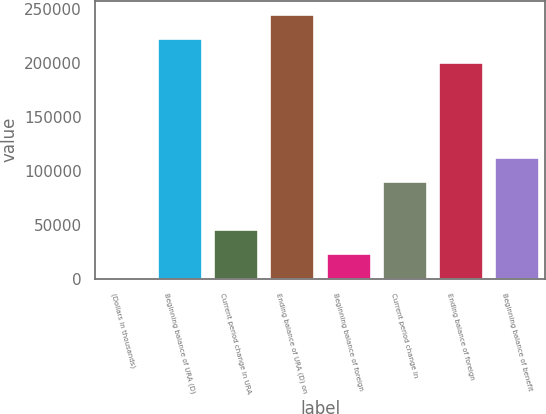Convert chart. <chart><loc_0><loc_0><loc_500><loc_500><bar_chart><fcel>(Dollars in thousands)<fcel>Beginning balance of URA (D)<fcel>Current period change in URA<fcel>Ending balance of URA (D) on<fcel>Beginning balance of foreign<fcel>Current period change in<fcel>Ending balance of foreign<fcel>Beginning balance of benefit<nl><fcel>2014<fcel>223250<fcel>46261.2<fcel>245374<fcel>24137.6<fcel>90508.4<fcel>201126<fcel>112632<nl></chart> 